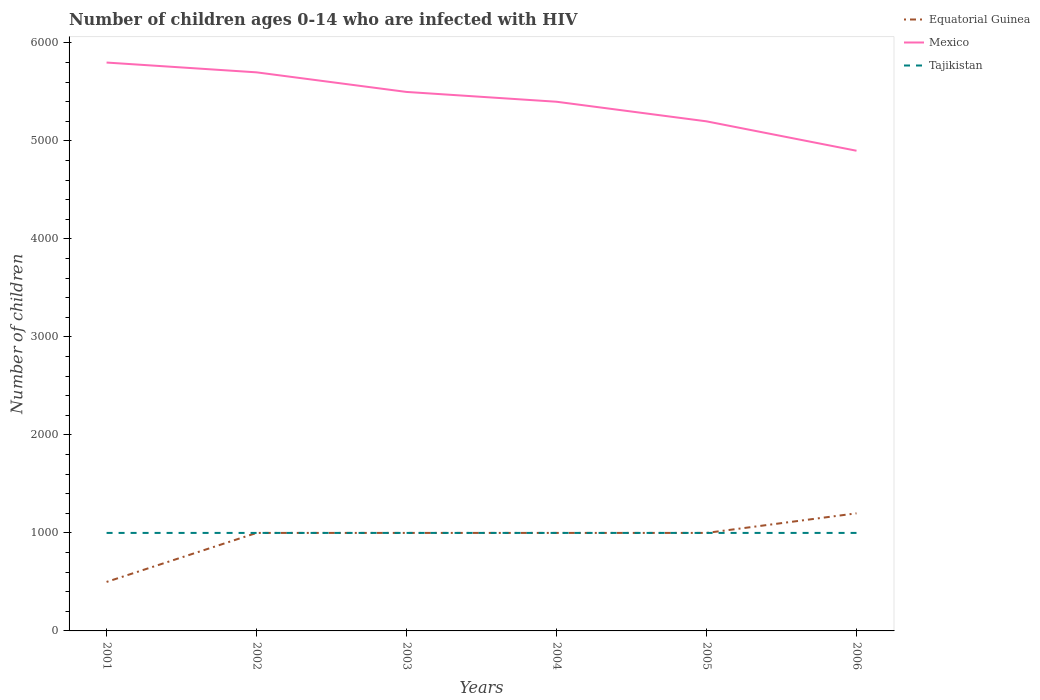Does the line corresponding to Equatorial Guinea intersect with the line corresponding to Mexico?
Provide a short and direct response. No. Across all years, what is the maximum number of HIV infected children in Mexico?
Make the answer very short. 4900. What is the total number of HIV infected children in Mexico in the graph?
Your answer should be compact. 500. What is the difference between the highest and the second highest number of HIV infected children in Equatorial Guinea?
Make the answer very short. 700. What is the difference between the highest and the lowest number of HIV infected children in Mexico?
Give a very brief answer. 3. Is the number of HIV infected children in Mexico strictly greater than the number of HIV infected children in Equatorial Guinea over the years?
Make the answer very short. No. Does the graph contain grids?
Give a very brief answer. No. How many legend labels are there?
Your response must be concise. 3. How are the legend labels stacked?
Provide a short and direct response. Vertical. What is the title of the graph?
Your answer should be very brief. Number of children ages 0-14 who are infected with HIV. What is the label or title of the X-axis?
Your answer should be very brief. Years. What is the label or title of the Y-axis?
Your answer should be very brief. Number of children. What is the Number of children in Mexico in 2001?
Your response must be concise. 5800. What is the Number of children in Mexico in 2002?
Your response must be concise. 5700. What is the Number of children of Mexico in 2003?
Keep it short and to the point. 5500. What is the Number of children of Mexico in 2004?
Provide a short and direct response. 5400. What is the Number of children in Equatorial Guinea in 2005?
Give a very brief answer. 1000. What is the Number of children of Mexico in 2005?
Provide a short and direct response. 5200. What is the Number of children in Equatorial Guinea in 2006?
Make the answer very short. 1200. What is the Number of children in Mexico in 2006?
Your answer should be very brief. 4900. Across all years, what is the maximum Number of children in Equatorial Guinea?
Give a very brief answer. 1200. Across all years, what is the maximum Number of children in Mexico?
Your answer should be compact. 5800. Across all years, what is the minimum Number of children in Equatorial Guinea?
Make the answer very short. 500. Across all years, what is the minimum Number of children of Mexico?
Your answer should be compact. 4900. Across all years, what is the minimum Number of children of Tajikistan?
Your answer should be very brief. 1000. What is the total Number of children in Equatorial Guinea in the graph?
Offer a very short reply. 5700. What is the total Number of children of Mexico in the graph?
Offer a terse response. 3.25e+04. What is the total Number of children in Tajikistan in the graph?
Your answer should be very brief. 6000. What is the difference between the Number of children in Equatorial Guinea in 2001 and that in 2002?
Offer a terse response. -500. What is the difference between the Number of children in Equatorial Guinea in 2001 and that in 2003?
Provide a short and direct response. -500. What is the difference between the Number of children in Mexico in 2001 and that in 2003?
Provide a succinct answer. 300. What is the difference between the Number of children in Tajikistan in 2001 and that in 2003?
Ensure brevity in your answer.  0. What is the difference between the Number of children in Equatorial Guinea in 2001 and that in 2004?
Keep it short and to the point. -500. What is the difference between the Number of children in Mexico in 2001 and that in 2004?
Offer a terse response. 400. What is the difference between the Number of children of Equatorial Guinea in 2001 and that in 2005?
Ensure brevity in your answer.  -500. What is the difference between the Number of children of Mexico in 2001 and that in 2005?
Your answer should be compact. 600. What is the difference between the Number of children of Equatorial Guinea in 2001 and that in 2006?
Give a very brief answer. -700. What is the difference between the Number of children in Mexico in 2001 and that in 2006?
Keep it short and to the point. 900. What is the difference between the Number of children of Tajikistan in 2001 and that in 2006?
Keep it short and to the point. 0. What is the difference between the Number of children in Tajikistan in 2002 and that in 2003?
Your answer should be very brief. 0. What is the difference between the Number of children of Mexico in 2002 and that in 2004?
Offer a terse response. 300. What is the difference between the Number of children in Mexico in 2002 and that in 2005?
Provide a succinct answer. 500. What is the difference between the Number of children in Equatorial Guinea in 2002 and that in 2006?
Your response must be concise. -200. What is the difference between the Number of children of Mexico in 2002 and that in 2006?
Your answer should be very brief. 800. What is the difference between the Number of children of Tajikistan in 2002 and that in 2006?
Give a very brief answer. 0. What is the difference between the Number of children of Equatorial Guinea in 2003 and that in 2004?
Offer a terse response. 0. What is the difference between the Number of children in Tajikistan in 2003 and that in 2004?
Your response must be concise. 0. What is the difference between the Number of children in Equatorial Guinea in 2003 and that in 2005?
Ensure brevity in your answer.  0. What is the difference between the Number of children in Mexico in 2003 and that in 2005?
Provide a succinct answer. 300. What is the difference between the Number of children in Tajikistan in 2003 and that in 2005?
Make the answer very short. 0. What is the difference between the Number of children of Equatorial Guinea in 2003 and that in 2006?
Your answer should be compact. -200. What is the difference between the Number of children in Mexico in 2003 and that in 2006?
Provide a short and direct response. 600. What is the difference between the Number of children in Mexico in 2004 and that in 2005?
Provide a short and direct response. 200. What is the difference between the Number of children in Tajikistan in 2004 and that in 2005?
Offer a terse response. 0. What is the difference between the Number of children of Equatorial Guinea in 2004 and that in 2006?
Provide a succinct answer. -200. What is the difference between the Number of children in Equatorial Guinea in 2005 and that in 2006?
Keep it short and to the point. -200. What is the difference between the Number of children in Mexico in 2005 and that in 2006?
Keep it short and to the point. 300. What is the difference between the Number of children of Equatorial Guinea in 2001 and the Number of children of Mexico in 2002?
Ensure brevity in your answer.  -5200. What is the difference between the Number of children in Equatorial Guinea in 2001 and the Number of children in Tajikistan in 2002?
Give a very brief answer. -500. What is the difference between the Number of children of Mexico in 2001 and the Number of children of Tajikistan in 2002?
Your answer should be compact. 4800. What is the difference between the Number of children of Equatorial Guinea in 2001 and the Number of children of Mexico in 2003?
Ensure brevity in your answer.  -5000. What is the difference between the Number of children of Equatorial Guinea in 2001 and the Number of children of Tajikistan in 2003?
Offer a terse response. -500. What is the difference between the Number of children in Mexico in 2001 and the Number of children in Tajikistan in 2003?
Make the answer very short. 4800. What is the difference between the Number of children of Equatorial Guinea in 2001 and the Number of children of Mexico in 2004?
Offer a terse response. -4900. What is the difference between the Number of children in Equatorial Guinea in 2001 and the Number of children in Tajikistan in 2004?
Keep it short and to the point. -500. What is the difference between the Number of children in Mexico in 2001 and the Number of children in Tajikistan in 2004?
Give a very brief answer. 4800. What is the difference between the Number of children of Equatorial Guinea in 2001 and the Number of children of Mexico in 2005?
Ensure brevity in your answer.  -4700. What is the difference between the Number of children in Equatorial Guinea in 2001 and the Number of children in Tajikistan in 2005?
Your answer should be compact. -500. What is the difference between the Number of children of Mexico in 2001 and the Number of children of Tajikistan in 2005?
Give a very brief answer. 4800. What is the difference between the Number of children in Equatorial Guinea in 2001 and the Number of children in Mexico in 2006?
Offer a very short reply. -4400. What is the difference between the Number of children of Equatorial Guinea in 2001 and the Number of children of Tajikistan in 2006?
Keep it short and to the point. -500. What is the difference between the Number of children of Mexico in 2001 and the Number of children of Tajikistan in 2006?
Keep it short and to the point. 4800. What is the difference between the Number of children of Equatorial Guinea in 2002 and the Number of children of Mexico in 2003?
Give a very brief answer. -4500. What is the difference between the Number of children of Equatorial Guinea in 2002 and the Number of children of Tajikistan in 2003?
Offer a terse response. 0. What is the difference between the Number of children in Mexico in 2002 and the Number of children in Tajikistan in 2003?
Your answer should be very brief. 4700. What is the difference between the Number of children in Equatorial Guinea in 2002 and the Number of children in Mexico in 2004?
Provide a short and direct response. -4400. What is the difference between the Number of children of Mexico in 2002 and the Number of children of Tajikistan in 2004?
Ensure brevity in your answer.  4700. What is the difference between the Number of children in Equatorial Guinea in 2002 and the Number of children in Mexico in 2005?
Provide a succinct answer. -4200. What is the difference between the Number of children in Mexico in 2002 and the Number of children in Tajikistan in 2005?
Make the answer very short. 4700. What is the difference between the Number of children of Equatorial Guinea in 2002 and the Number of children of Mexico in 2006?
Give a very brief answer. -3900. What is the difference between the Number of children in Equatorial Guinea in 2002 and the Number of children in Tajikistan in 2006?
Provide a short and direct response. 0. What is the difference between the Number of children in Mexico in 2002 and the Number of children in Tajikistan in 2006?
Give a very brief answer. 4700. What is the difference between the Number of children in Equatorial Guinea in 2003 and the Number of children in Mexico in 2004?
Your response must be concise. -4400. What is the difference between the Number of children in Mexico in 2003 and the Number of children in Tajikistan in 2004?
Give a very brief answer. 4500. What is the difference between the Number of children in Equatorial Guinea in 2003 and the Number of children in Mexico in 2005?
Give a very brief answer. -4200. What is the difference between the Number of children in Mexico in 2003 and the Number of children in Tajikistan in 2005?
Give a very brief answer. 4500. What is the difference between the Number of children of Equatorial Guinea in 2003 and the Number of children of Mexico in 2006?
Make the answer very short. -3900. What is the difference between the Number of children of Mexico in 2003 and the Number of children of Tajikistan in 2006?
Make the answer very short. 4500. What is the difference between the Number of children of Equatorial Guinea in 2004 and the Number of children of Mexico in 2005?
Make the answer very short. -4200. What is the difference between the Number of children in Mexico in 2004 and the Number of children in Tajikistan in 2005?
Your answer should be very brief. 4400. What is the difference between the Number of children in Equatorial Guinea in 2004 and the Number of children in Mexico in 2006?
Offer a very short reply. -3900. What is the difference between the Number of children in Mexico in 2004 and the Number of children in Tajikistan in 2006?
Offer a terse response. 4400. What is the difference between the Number of children in Equatorial Guinea in 2005 and the Number of children in Mexico in 2006?
Offer a terse response. -3900. What is the difference between the Number of children of Mexico in 2005 and the Number of children of Tajikistan in 2006?
Your response must be concise. 4200. What is the average Number of children of Equatorial Guinea per year?
Offer a very short reply. 950. What is the average Number of children of Mexico per year?
Keep it short and to the point. 5416.67. In the year 2001, what is the difference between the Number of children in Equatorial Guinea and Number of children in Mexico?
Provide a short and direct response. -5300. In the year 2001, what is the difference between the Number of children of Equatorial Guinea and Number of children of Tajikistan?
Your response must be concise. -500. In the year 2001, what is the difference between the Number of children of Mexico and Number of children of Tajikistan?
Your response must be concise. 4800. In the year 2002, what is the difference between the Number of children of Equatorial Guinea and Number of children of Mexico?
Keep it short and to the point. -4700. In the year 2002, what is the difference between the Number of children of Mexico and Number of children of Tajikistan?
Provide a succinct answer. 4700. In the year 2003, what is the difference between the Number of children in Equatorial Guinea and Number of children in Mexico?
Offer a very short reply. -4500. In the year 2003, what is the difference between the Number of children in Mexico and Number of children in Tajikistan?
Keep it short and to the point. 4500. In the year 2004, what is the difference between the Number of children in Equatorial Guinea and Number of children in Mexico?
Make the answer very short. -4400. In the year 2004, what is the difference between the Number of children of Equatorial Guinea and Number of children of Tajikistan?
Give a very brief answer. 0. In the year 2004, what is the difference between the Number of children of Mexico and Number of children of Tajikistan?
Offer a terse response. 4400. In the year 2005, what is the difference between the Number of children of Equatorial Guinea and Number of children of Mexico?
Provide a short and direct response. -4200. In the year 2005, what is the difference between the Number of children in Mexico and Number of children in Tajikistan?
Ensure brevity in your answer.  4200. In the year 2006, what is the difference between the Number of children of Equatorial Guinea and Number of children of Mexico?
Ensure brevity in your answer.  -3700. In the year 2006, what is the difference between the Number of children in Mexico and Number of children in Tajikistan?
Keep it short and to the point. 3900. What is the ratio of the Number of children of Equatorial Guinea in 2001 to that in 2002?
Ensure brevity in your answer.  0.5. What is the ratio of the Number of children in Mexico in 2001 to that in 2002?
Make the answer very short. 1.02. What is the ratio of the Number of children in Tajikistan in 2001 to that in 2002?
Ensure brevity in your answer.  1. What is the ratio of the Number of children of Mexico in 2001 to that in 2003?
Make the answer very short. 1.05. What is the ratio of the Number of children of Mexico in 2001 to that in 2004?
Provide a succinct answer. 1.07. What is the ratio of the Number of children of Equatorial Guinea in 2001 to that in 2005?
Your answer should be compact. 0.5. What is the ratio of the Number of children of Mexico in 2001 to that in 2005?
Give a very brief answer. 1.12. What is the ratio of the Number of children of Equatorial Guinea in 2001 to that in 2006?
Ensure brevity in your answer.  0.42. What is the ratio of the Number of children in Mexico in 2001 to that in 2006?
Offer a terse response. 1.18. What is the ratio of the Number of children in Mexico in 2002 to that in 2003?
Provide a short and direct response. 1.04. What is the ratio of the Number of children in Tajikistan in 2002 to that in 2003?
Offer a terse response. 1. What is the ratio of the Number of children of Equatorial Guinea in 2002 to that in 2004?
Provide a short and direct response. 1. What is the ratio of the Number of children in Mexico in 2002 to that in 2004?
Give a very brief answer. 1.06. What is the ratio of the Number of children of Tajikistan in 2002 to that in 2004?
Your response must be concise. 1. What is the ratio of the Number of children in Mexico in 2002 to that in 2005?
Make the answer very short. 1.1. What is the ratio of the Number of children in Tajikistan in 2002 to that in 2005?
Provide a short and direct response. 1. What is the ratio of the Number of children in Mexico in 2002 to that in 2006?
Offer a terse response. 1.16. What is the ratio of the Number of children of Mexico in 2003 to that in 2004?
Give a very brief answer. 1.02. What is the ratio of the Number of children in Tajikistan in 2003 to that in 2004?
Your answer should be compact. 1. What is the ratio of the Number of children of Equatorial Guinea in 2003 to that in 2005?
Your response must be concise. 1. What is the ratio of the Number of children of Mexico in 2003 to that in 2005?
Offer a terse response. 1.06. What is the ratio of the Number of children of Equatorial Guinea in 2003 to that in 2006?
Provide a succinct answer. 0.83. What is the ratio of the Number of children of Mexico in 2003 to that in 2006?
Offer a terse response. 1.12. What is the ratio of the Number of children in Tajikistan in 2003 to that in 2006?
Offer a terse response. 1. What is the ratio of the Number of children in Equatorial Guinea in 2004 to that in 2005?
Your answer should be very brief. 1. What is the ratio of the Number of children of Mexico in 2004 to that in 2005?
Ensure brevity in your answer.  1.04. What is the ratio of the Number of children of Tajikistan in 2004 to that in 2005?
Offer a terse response. 1. What is the ratio of the Number of children of Equatorial Guinea in 2004 to that in 2006?
Make the answer very short. 0.83. What is the ratio of the Number of children in Mexico in 2004 to that in 2006?
Keep it short and to the point. 1.1. What is the ratio of the Number of children of Tajikistan in 2004 to that in 2006?
Keep it short and to the point. 1. What is the ratio of the Number of children of Mexico in 2005 to that in 2006?
Make the answer very short. 1.06. What is the difference between the highest and the second highest Number of children in Equatorial Guinea?
Your answer should be very brief. 200. What is the difference between the highest and the second highest Number of children in Mexico?
Offer a terse response. 100. What is the difference between the highest and the second highest Number of children in Tajikistan?
Make the answer very short. 0. What is the difference between the highest and the lowest Number of children of Equatorial Guinea?
Keep it short and to the point. 700. What is the difference between the highest and the lowest Number of children of Mexico?
Make the answer very short. 900. 